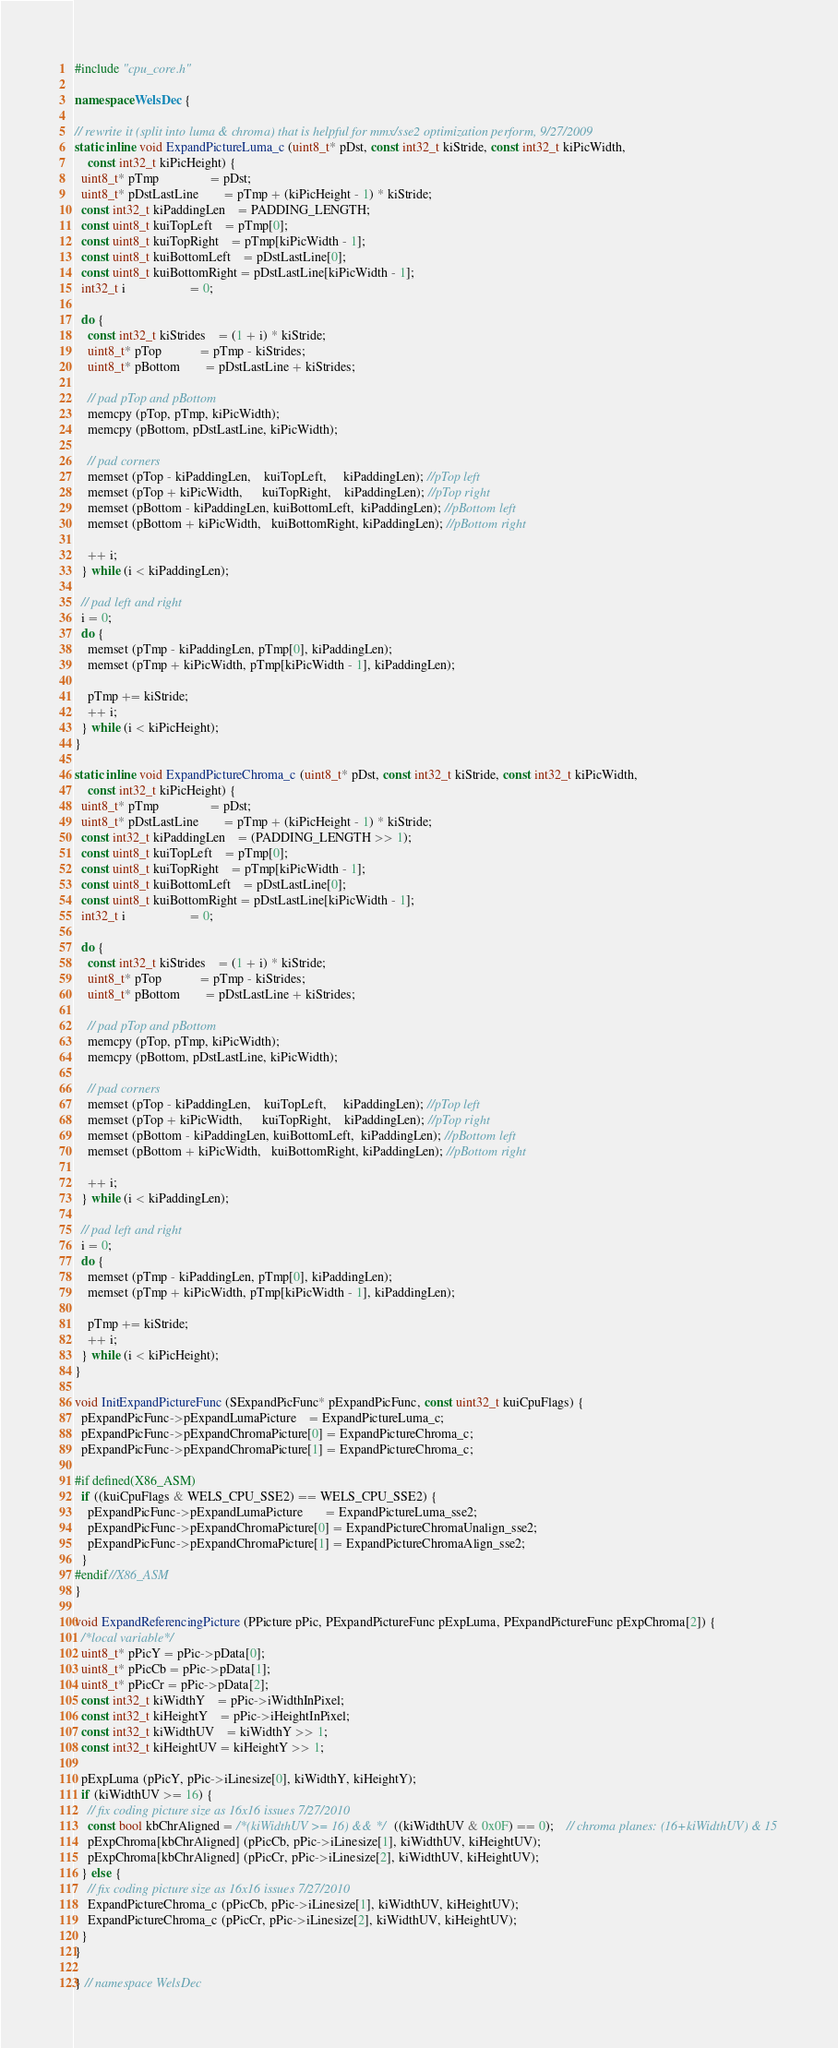<code> <loc_0><loc_0><loc_500><loc_500><_C++_>#include "cpu_core.h"

namespace WelsDec {

// rewrite it (split into luma & chroma) that is helpful for mmx/sse2 optimization perform, 9/27/2009
static inline void ExpandPictureLuma_c (uint8_t* pDst, const int32_t kiStride, const int32_t kiPicWidth,
    const int32_t kiPicHeight) {
  uint8_t* pTmp				= pDst;
  uint8_t* pDstLastLine		= pTmp + (kiPicHeight - 1) * kiStride;
  const int32_t kiPaddingLen	= PADDING_LENGTH;
  const uint8_t kuiTopLeft	= pTmp[0];
  const uint8_t kuiTopRight	= pTmp[kiPicWidth - 1];
  const uint8_t kuiBottomLeft	= pDstLastLine[0];
  const uint8_t kuiBottomRight = pDstLastLine[kiPicWidth - 1];
  int32_t i					= 0;

  do {
    const int32_t kiStrides	= (1 + i) * kiStride;
    uint8_t* pTop			= pTmp - kiStrides;
    uint8_t* pBottom		= pDstLastLine + kiStrides;

    // pad pTop and pBottom
    memcpy (pTop, pTmp, kiPicWidth);
    memcpy (pBottom, pDstLastLine, kiPicWidth);

    // pad corners
    memset (pTop - kiPaddingLen,    kuiTopLeft,     kiPaddingLen); //pTop left
    memset (pTop + kiPicWidth,      kuiTopRight,    kiPaddingLen); //pTop right
    memset (pBottom - kiPaddingLen, kuiBottomLeft,  kiPaddingLen); //pBottom left
    memset (pBottom + kiPicWidth,   kuiBottomRight, kiPaddingLen); //pBottom right

    ++ i;
  } while (i < kiPaddingLen);

  // pad left and right
  i = 0;
  do {
    memset (pTmp - kiPaddingLen, pTmp[0], kiPaddingLen);
    memset (pTmp + kiPicWidth, pTmp[kiPicWidth - 1], kiPaddingLen);

    pTmp += kiStride;
    ++ i;
  } while (i < kiPicHeight);
}

static inline void ExpandPictureChroma_c (uint8_t* pDst, const int32_t kiStride, const int32_t kiPicWidth,
    const int32_t kiPicHeight) {
  uint8_t* pTmp				= pDst;
  uint8_t* pDstLastLine		= pTmp + (kiPicHeight - 1) * kiStride;
  const int32_t kiPaddingLen	= (PADDING_LENGTH >> 1);
  const uint8_t kuiTopLeft	= pTmp[0];
  const uint8_t kuiTopRight	= pTmp[kiPicWidth - 1];
  const uint8_t kuiBottomLeft	= pDstLastLine[0];
  const uint8_t kuiBottomRight = pDstLastLine[kiPicWidth - 1];
  int32_t i					= 0;

  do {
    const int32_t kiStrides	= (1 + i) * kiStride;
    uint8_t* pTop			= pTmp - kiStrides;
    uint8_t* pBottom		= pDstLastLine + kiStrides;

    // pad pTop and pBottom
    memcpy (pTop, pTmp, kiPicWidth);
    memcpy (pBottom, pDstLastLine, kiPicWidth);

    // pad corners
    memset (pTop - kiPaddingLen,    kuiTopLeft,     kiPaddingLen); //pTop left
    memset (pTop + kiPicWidth,      kuiTopRight,    kiPaddingLen); //pTop right
    memset (pBottom - kiPaddingLen, kuiBottomLeft,  kiPaddingLen); //pBottom left
    memset (pBottom + kiPicWidth,   kuiBottomRight, kiPaddingLen); //pBottom right

    ++ i;
  } while (i < kiPaddingLen);

  // pad left and right
  i = 0;
  do {
    memset (pTmp - kiPaddingLen, pTmp[0], kiPaddingLen);
    memset (pTmp + kiPicWidth, pTmp[kiPicWidth - 1], kiPaddingLen);

    pTmp += kiStride;
    ++ i;
  } while (i < kiPicHeight);
}

void InitExpandPictureFunc (SExpandPicFunc* pExpandPicFunc, const uint32_t kuiCpuFlags) {
  pExpandPicFunc->pExpandLumaPicture	= ExpandPictureLuma_c;
  pExpandPicFunc->pExpandChromaPicture[0] = ExpandPictureChroma_c;
  pExpandPicFunc->pExpandChromaPicture[1] = ExpandPictureChroma_c;

#if defined(X86_ASM)
  if ((kuiCpuFlags & WELS_CPU_SSE2) == WELS_CPU_SSE2) {
    pExpandPicFunc->pExpandLumaPicture	   = ExpandPictureLuma_sse2;
    pExpandPicFunc->pExpandChromaPicture[0] = ExpandPictureChromaUnalign_sse2;
    pExpandPicFunc->pExpandChromaPicture[1] = ExpandPictureChromaAlign_sse2;
  }
#endif//X86_ASM
}

void ExpandReferencingPicture (PPicture pPic, PExpandPictureFunc pExpLuma, PExpandPictureFunc pExpChroma[2]) {
  /*local variable*/
  uint8_t* pPicY = pPic->pData[0];
  uint8_t* pPicCb = pPic->pData[1];
  uint8_t* pPicCr = pPic->pData[2];
  const int32_t kiWidthY	= pPic->iWidthInPixel;
  const int32_t kiHeightY	= pPic->iHeightInPixel;
  const int32_t kiWidthUV	= kiWidthY >> 1;
  const int32_t kiHeightUV = kiHeightY >> 1;

  pExpLuma (pPicY, pPic->iLinesize[0], kiWidthY, kiHeightY);
  if (kiWidthUV >= 16) {
    // fix coding picture size as 16x16 issues 7/27/2010
    const bool kbChrAligned = /*(kiWidthUV >= 16) && */ ((kiWidthUV & 0x0F) == 0);	// chroma planes: (16+kiWidthUV) & 15
    pExpChroma[kbChrAligned] (pPicCb, pPic->iLinesize[1], kiWidthUV, kiHeightUV);
    pExpChroma[kbChrAligned] (pPicCr, pPic->iLinesize[2], kiWidthUV, kiHeightUV);
  } else {
    // fix coding picture size as 16x16 issues 7/27/2010
    ExpandPictureChroma_c (pPicCb, pPic->iLinesize[1], kiWidthUV, kiHeightUV);
    ExpandPictureChroma_c (pPicCr, pPic->iLinesize[2], kiWidthUV, kiHeightUV);
  }
}

} // namespace WelsDec
</code> 